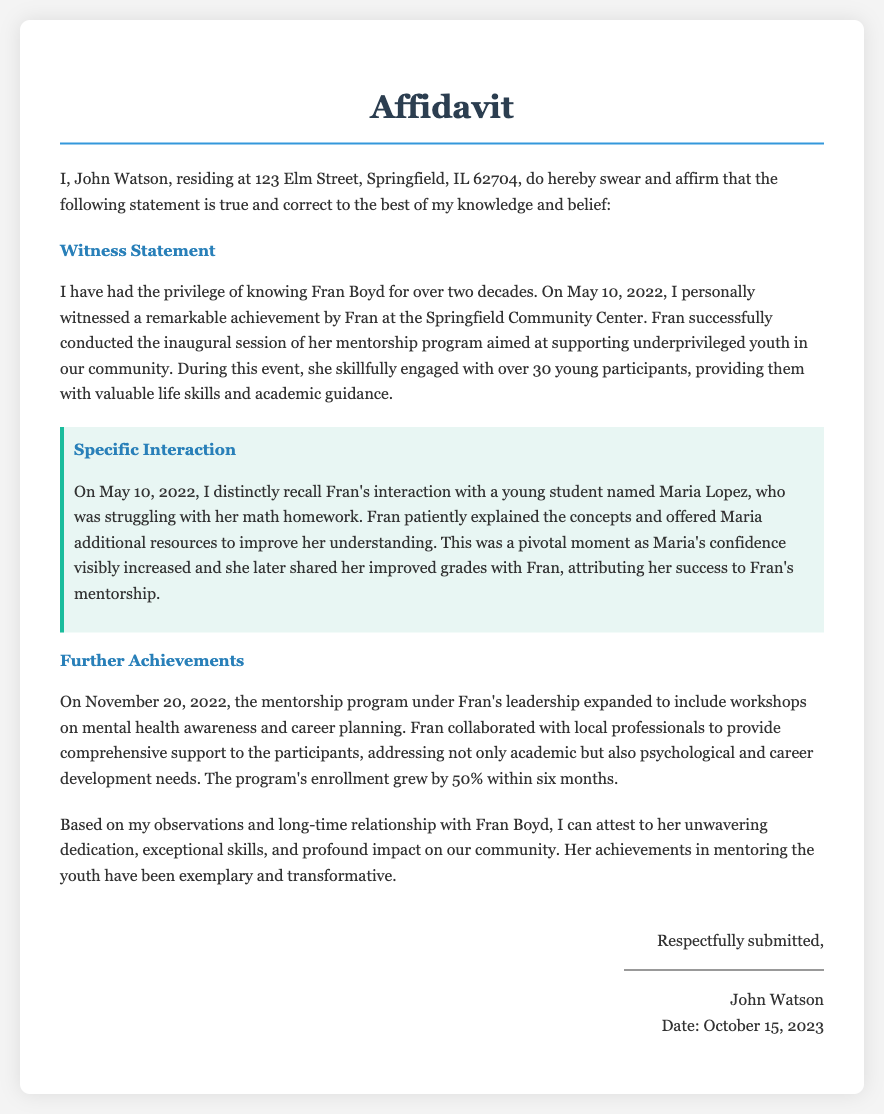What is the name of the witness? The witness name is mentioned at the beginning of the affidavit as John Watson.
Answer: John Watson What was the date of Fran Boyd's mentorship program's inaugural session? The specific date of the inaugural session is stated in the document as May 10, 2022.
Answer: May 10, 2022 How many young participants attended the inaugural session? The document specifies that over 30 young participants were engaged during the event.
Answer: over 30 Who did Fran Boyd help with math homework? The affidavit mentions that Fran helped a young student named Maria Lopez with her math homework.
Answer: Maria Lopez What was the enrollment increase in the mentorship program after six months? The document states that the program's enrollment grew by 50% within six months.
Answer: 50% What type of workshops were added to the mentorship program on November 20, 2022? The document indicates that workshops on mental health awareness and career planning were added to the program.
Answer: mental health awareness and career planning What is the address of the witness? The affidavit lists the witness's address as 123 Elm Street, Springfield, IL 62704.
Answer: 123 Elm Street, Springfield, IL 62704 What is the date on which this affidavit was signed? The document specifies that the affidavit was signed on October 15, 2023.
Answer: October 15, 2023 